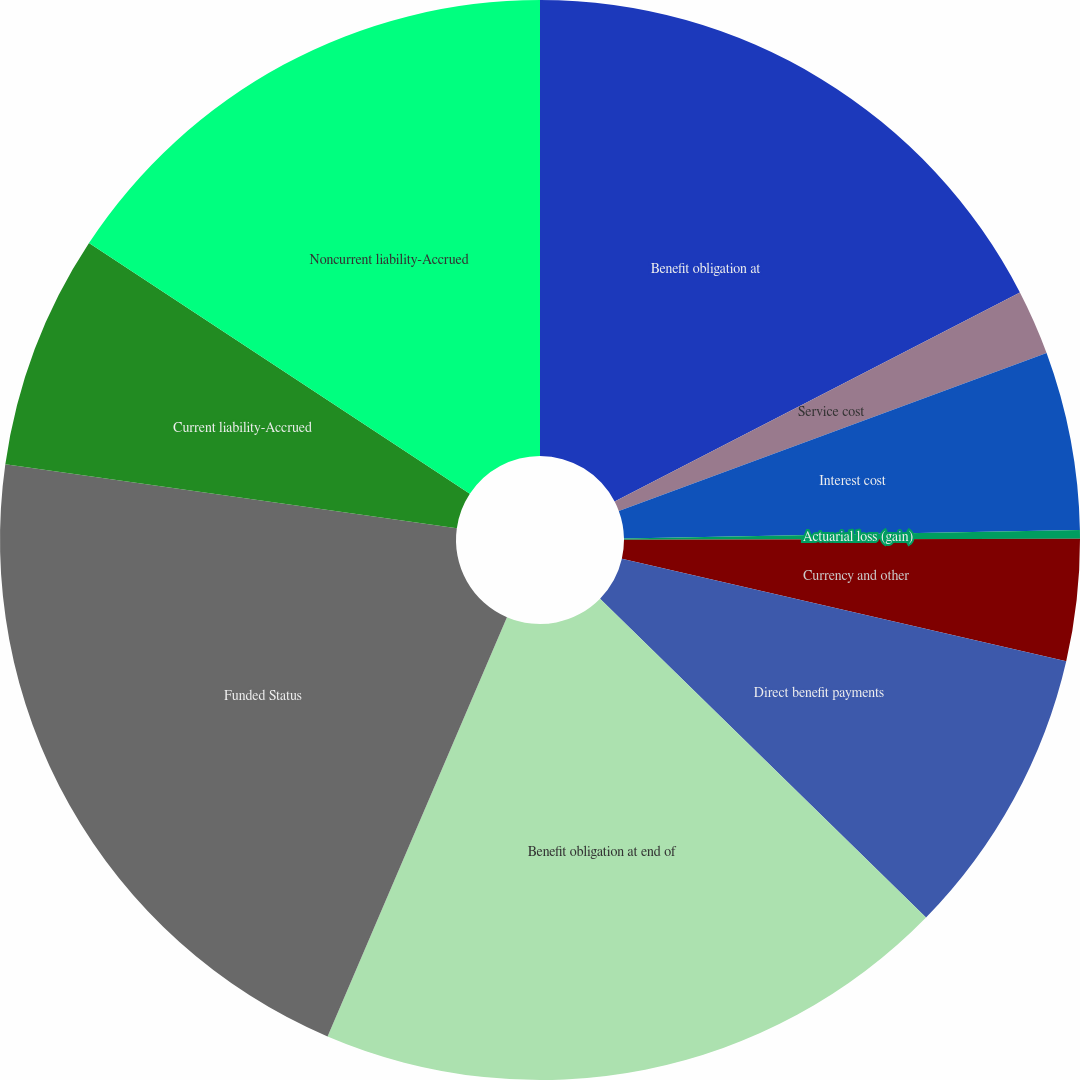Convert chart. <chart><loc_0><loc_0><loc_500><loc_500><pie_chart><fcel>Benefit obligation at<fcel>Service cost<fcel>Interest cost<fcel>Actuarial loss (gain)<fcel>Currency and other<fcel>Direct benefit payments<fcel>Benefit obligation at end of<fcel>Funded Status<fcel>Current liability-Accrued<fcel>Noncurrent liability-Accrued<nl><fcel>17.42%<fcel>1.95%<fcel>5.33%<fcel>0.26%<fcel>3.64%<fcel>8.72%<fcel>19.11%<fcel>20.8%<fcel>7.03%<fcel>15.73%<nl></chart> 